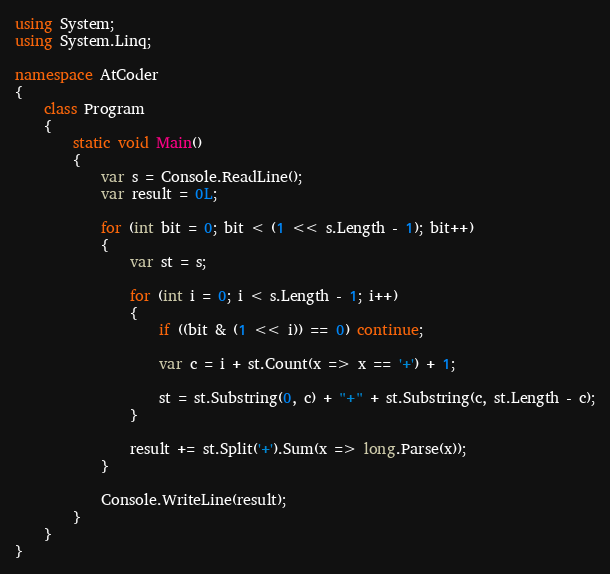<code> <loc_0><loc_0><loc_500><loc_500><_C#_>using System;
using System.Linq;

namespace AtCoder
{
    class Program
    {
        static void Main()
        {
            var s = Console.ReadLine();
            var result = 0L;

            for (int bit = 0; bit < (1 << s.Length - 1); bit++)
            {
                var st = s;

                for (int i = 0; i < s.Length - 1; i++)
                {
                    if ((bit & (1 << i)) == 0) continue;

                    var c = i + st.Count(x => x == '+') + 1;

                    st = st.Substring(0, c) + "+" + st.Substring(c, st.Length - c);
                }

                result += st.Split('+').Sum(x => long.Parse(x));
            }

            Console.WriteLine(result);
        }
    }
}</code> 